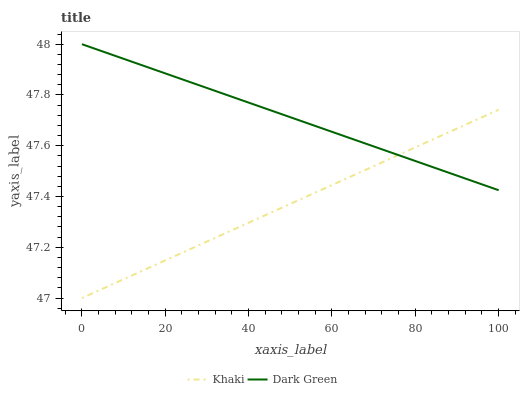Does Khaki have the minimum area under the curve?
Answer yes or no. Yes. Does Dark Green have the maximum area under the curve?
Answer yes or no. Yes. Does Dark Green have the minimum area under the curve?
Answer yes or no. No. Is Dark Green the smoothest?
Answer yes or no. Yes. Is Khaki the roughest?
Answer yes or no. Yes. Is Dark Green the roughest?
Answer yes or no. No. Does Khaki have the lowest value?
Answer yes or no. Yes. Does Dark Green have the lowest value?
Answer yes or no. No. Does Dark Green have the highest value?
Answer yes or no. Yes. Does Khaki intersect Dark Green?
Answer yes or no. Yes. Is Khaki less than Dark Green?
Answer yes or no. No. Is Khaki greater than Dark Green?
Answer yes or no. No. 